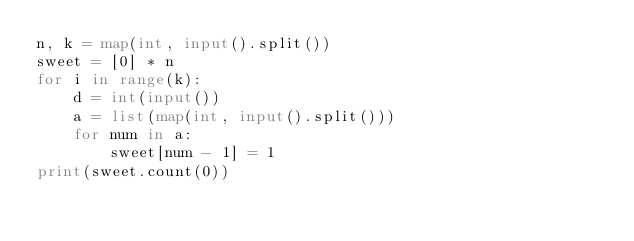<code> <loc_0><loc_0><loc_500><loc_500><_Python_>n, k = map(int, input().split())
sweet = [0] * n
for i in range(k):
    d = int(input())
    a = list(map(int, input().split()))
    for num in a:
        sweet[num - 1] = 1
print(sweet.count(0))
</code> 